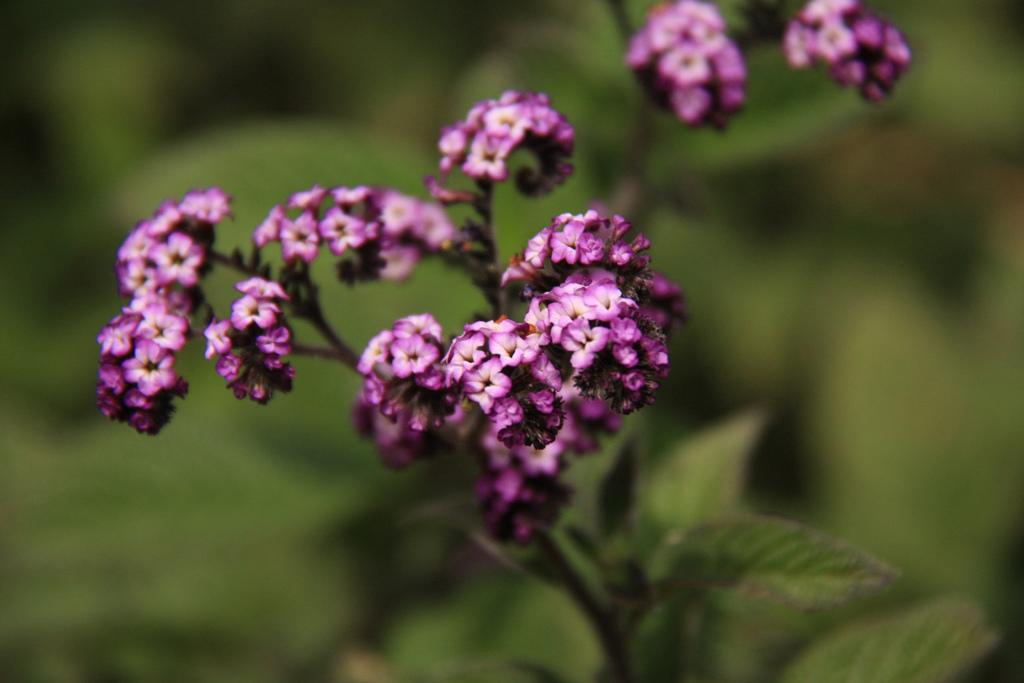What type of flora is present in the image? There are flowers in the image. What colors are the flowers? The flowers are white and purple in color. What other part of the plant can be seen in the image? There are green leaves in the image. What is the color of the background in the image? The background of the image is green. What decision did the flowers make in the image? There is no decision-making process depicted in the image, as flowers do not have the ability to make decisions. 